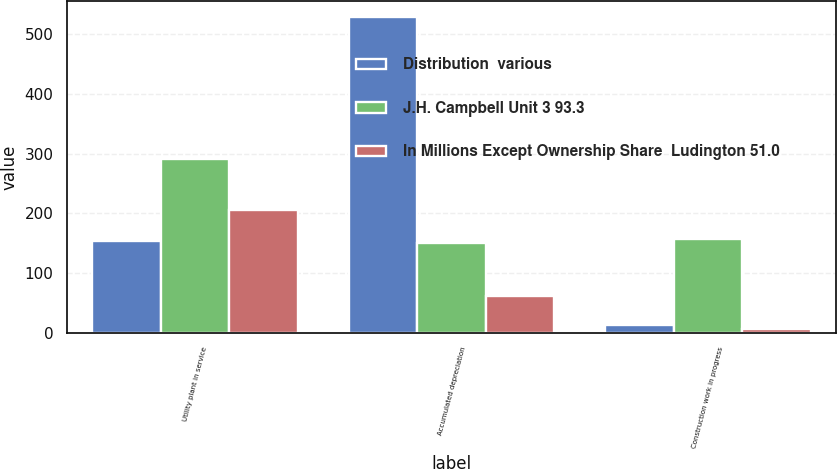Convert chart to OTSL. <chart><loc_0><loc_0><loc_500><loc_500><stacked_bar_chart><ecel><fcel>Utility plant in service<fcel>Accumulated depreciation<fcel>Construction work in progress<nl><fcel>Distribution  various<fcel>153.5<fcel>529<fcel>13<nl><fcel>J.H. Campbell Unit 3 93.3<fcel>291<fcel>150<fcel>157<nl><fcel>In Millions Except Ownership Share  Ludington 51.0<fcel>206<fcel>63<fcel>7<nl></chart> 